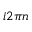<formula> <loc_0><loc_0><loc_500><loc_500>i 2 \pi n</formula> 